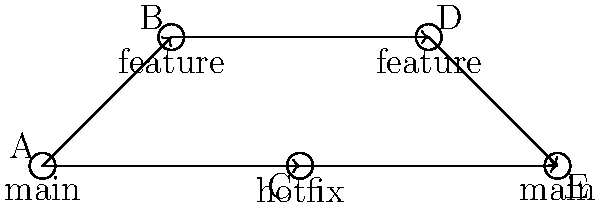As a newbie web developer learning to set up a website with GitHub Pages, you're studying Git branching strategies. The diagram above represents a Git workflow. Which of the following sequences correctly describes the branching and merging process shown in the diagram?

A) main → feature → hotfix → feature → main
B) main → feature → main → hotfix → feature
C) main → (feature & hotfix) → feature → main
D) hotfix → main → feature → feature → main Let's analyze the Git branching diagram step-by-step:

1. We start at node A, which represents the main branch.

2. From A, we see two branches diverging:
   - One goes up to node B (likely a feature branch)
   - One goes straight to node C (likely a hotfix branch)

3. The feature branch (upper path) continues from B to D.

4. The hotfix branch (lower path) goes from C directly to E.

5. The feature branch then merges back into the main branch at node E.

6. Node E represents the final state of the main branch after both the hotfix and feature branches have been merged.

This workflow represents a common Git branching strategy where:
- A feature branch is created for developing new features
- A hotfix branch is created for urgent fixes
- Both branches are eventually merged back into the main branch

The correct sequence that describes this process is:
main (A) → (feature (B) & hotfix (C)) → feature (D) → main (E)

This matches option C in the question.
Answer: C) main → (feature & hotfix) → feature → main 